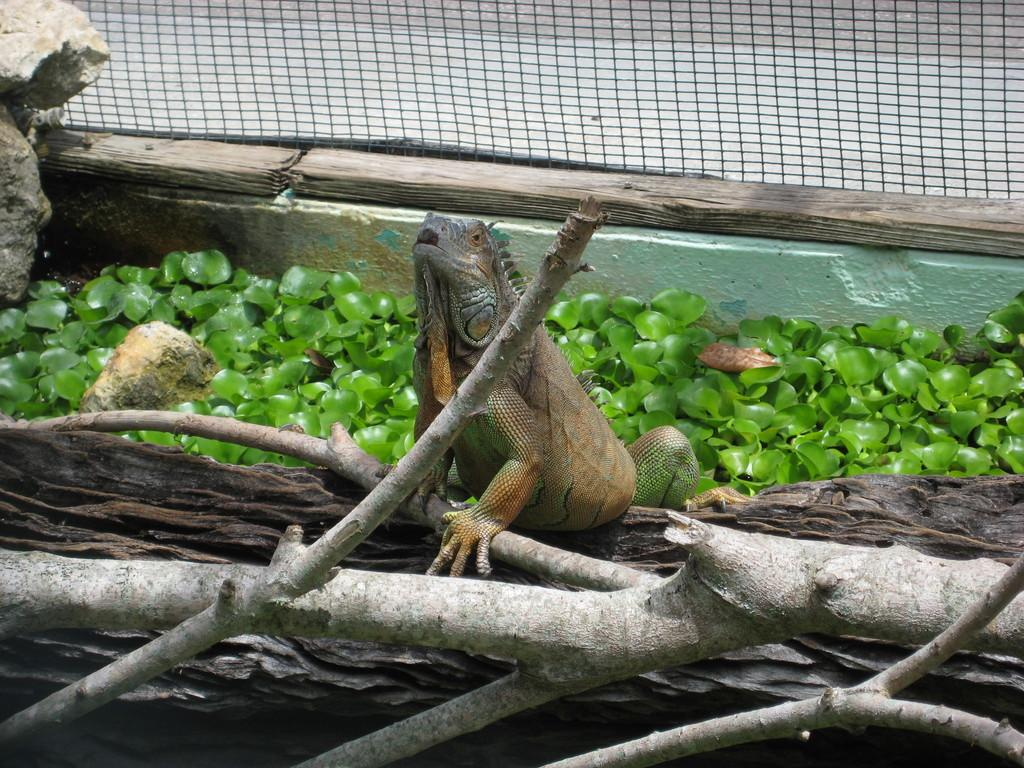What animal is present in the image? There is a chameleon in the image. Where is the chameleon located? The chameleon is on a wooden trunk. What can be seen in the background of the image? There are plants in the background of the image. How are the plants positioned in the image? The plants are on the ground. What other object can be seen in the image? There is a fence in the image. What type of flame can be seen burning near the chameleon in the image? There is no flame present in the image; it features a chameleon on a wooden trunk with plants and a fence in the background. 